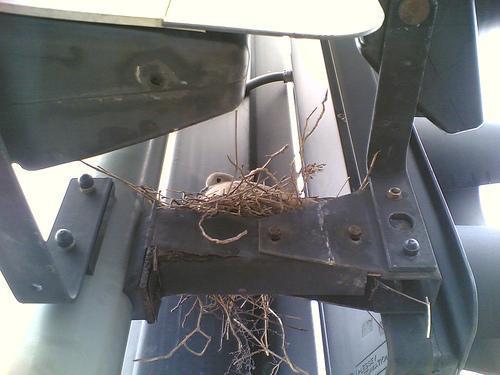How many bolts are visible?
Give a very brief answer. 6. 